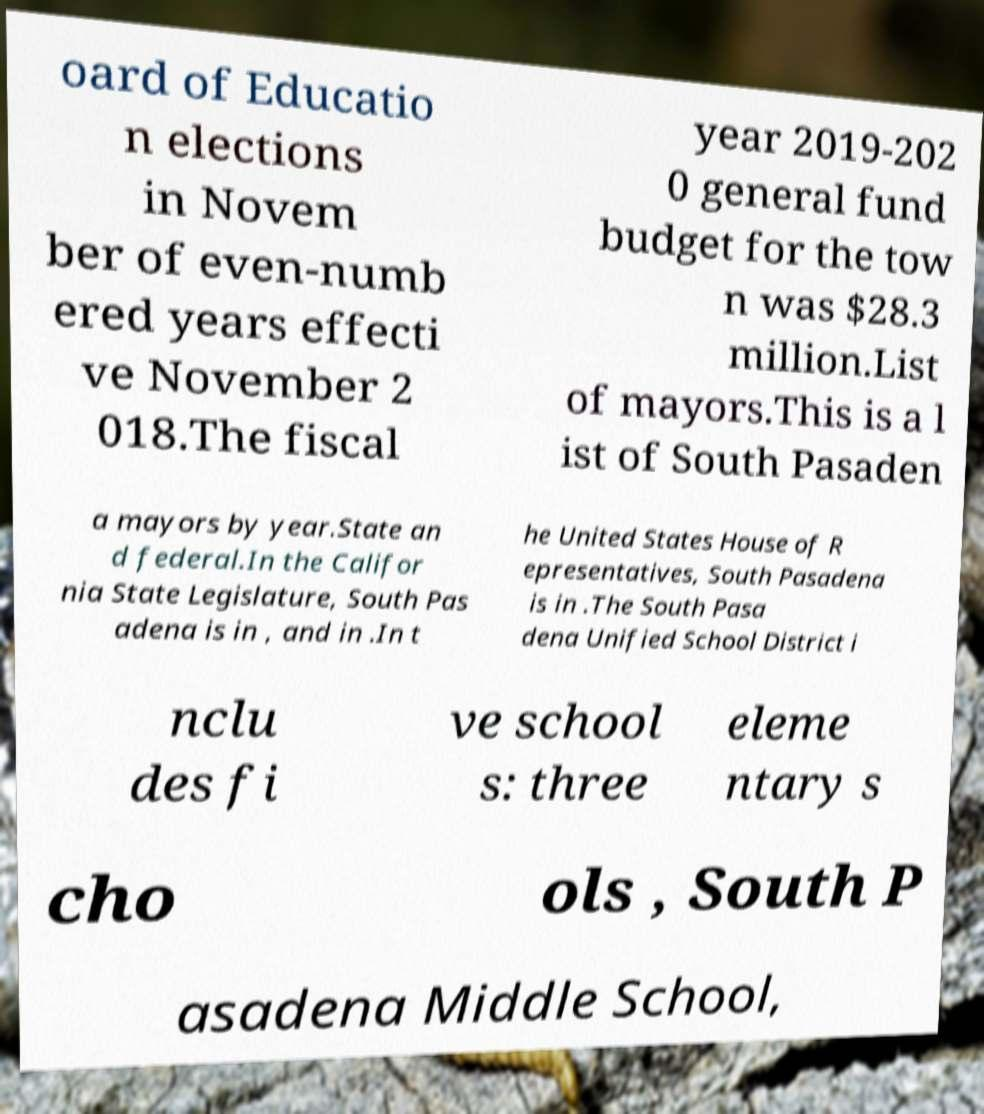Can you accurately transcribe the text from the provided image for me? oard of Educatio n elections in Novem ber of even-numb ered years effecti ve November 2 018.The fiscal year 2019-202 0 general fund budget for the tow n was $28.3 million.List of mayors.This is a l ist of South Pasaden a mayors by year.State an d federal.In the Califor nia State Legislature, South Pas adena is in , and in .In t he United States House of R epresentatives, South Pasadena is in .The South Pasa dena Unified School District i nclu des fi ve school s: three eleme ntary s cho ols , South P asadena Middle School, 